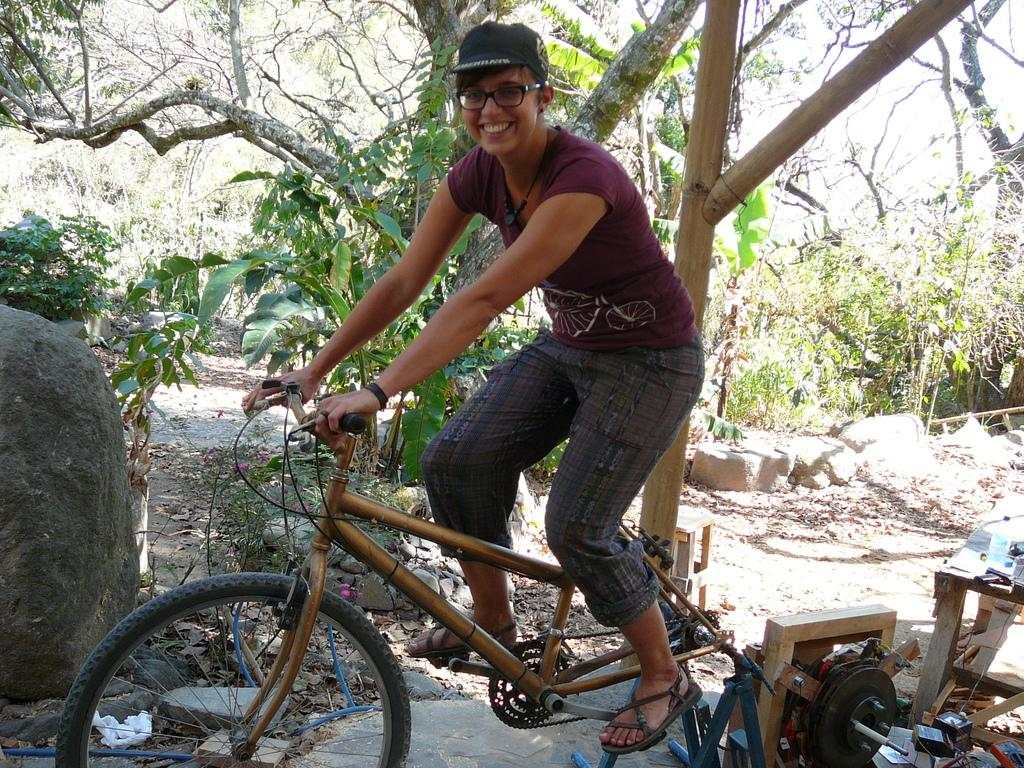What is the woman in the image doing? The woman is sitting on a bicycle in the image. What can be seen on the floor in the image? There are machines on the floor in the image. What type of natural elements are present in the image? Rocks and stones are present in the image, as well as trees. What is the condition of the leaves in the image? Shredded leaves are visible in the image. What is visible in the background of the image? The sky is visible in the image. What type of arm is visible in the image? There is no arm present in the image. Can you describe the monkey's behavior in the image? There is no monkey present in the image. 